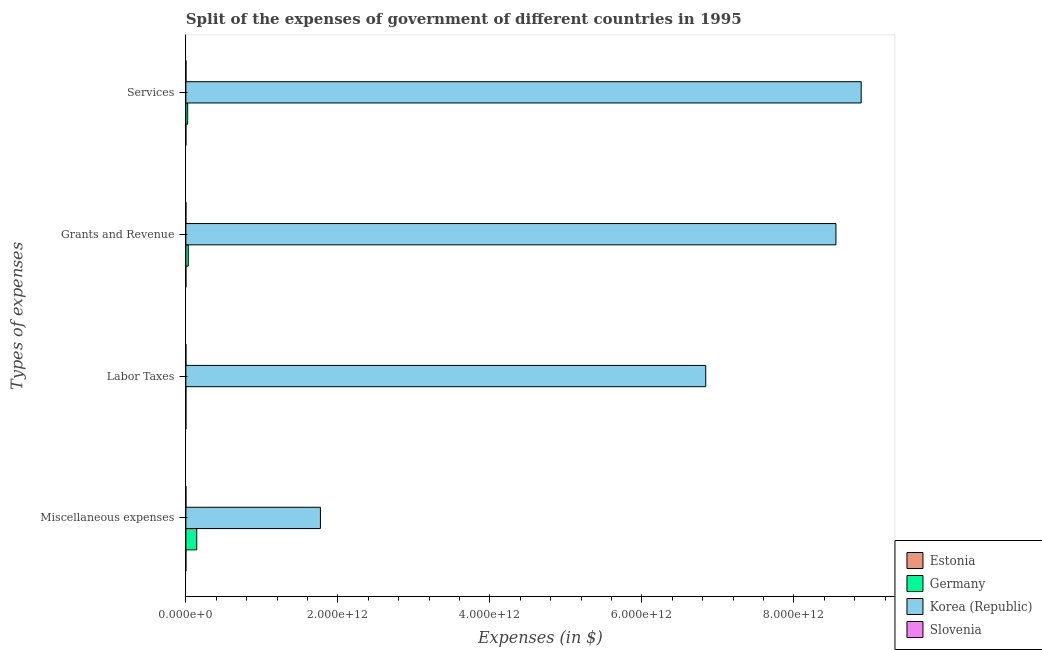How many groups of bars are there?
Your answer should be very brief. 4. Are the number of bars on each tick of the Y-axis equal?
Make the answer very short. Yes. How many bars are there on the 4th tick from the bottom?
Provide a succinct answer. 4. What is the label of the 3rd group of bars from the top?
Keep it short and to the point. Labor Taxes. What is the amount spent on labor taxes in Estonia?
Give a very brief answer. 2.84e+06. Across all countries, what is the maximum amount spent on miscellaneous expenses?
Give a very brief answer. 1.77e+12. Across all countries, what is the minimum amount spent on labor taxes?
Offer a very short reply. 2.84e+06. In which country was the amount spent on grants and revenue maximum?
Provide a succinct answer. Korea (Republic). In which country was the amount spent on services minimum?
Your response must be concise. Estonia. What is the total amount spent on labor taxes in the graph?
Give a very brief answer. 6.84e+12. What is the difference between the amount spent on services in Slovenia and that in Germany?
Ensure brevity in your answer.  -2.29e+1. What is the difference between the amount spent on services in Estonia and the amount spent on labor taxes in Slovenia?
Your answer should be compact. 1.77e+08. What is the average amount spent on labor taxes per country?
Keep it short and to the point. 1.71e+12. What is the difference between the amount spent on services and amount spent on labor taxes in Korea (Republic)?
Make the answer very short. 2.04e+12. What is the ratio of the amount spent on grants and revenue in Slovenia to that in Germany?
Your answer should be compact. 0. Is the amount spent on services in Germany less than that in Slovenia?
Ensure brevity in your answer.  No. Is the difference between the amount spent on grants and revenue in Germany and Korea (Republic) greater than the difference between the amount spent on miscellaneous expenses in Germany and Korea (Republic)?
Give a very brief answer. No. What is the difference between the highest and the second highest amount spent on labor taxes?
Offer a terse response. 6.84e+12. What is the difference between the highest and the lowest amount spent on labor taxes?
Provide a succinct answer. 6.84e+12. In how many countries, is the amount spent on grants and revenue greater than the average amount spent on grants and revenue taken over all countries?
Your answer should be compact. 1. Is it the case that in every country, the sum of the amount spent on grants and revenue and amount spent on miscellaneous expenses is greater than the sum of amount spent on labor taxes and amount spent on services?
Your response must be concise. No. What does the 1st bar from the bottom in Grants and Revenue represents?
Provide a succinct answer. Estonia. Is it the case that in every country, the sum of the amount spent on miscellaneous expenses and amount spent on labor taxes is greater than the amount spent on grants and revenue?
Your answer should be compact. No. Are all the bars in the graph horizontal?
Keep it short and to the point. Yes. What is the difference between two consecutive major ticks on the X-axis?
Offer a very short reply. 2.00e+12. Are the values on the major ticks of X-axis written in scientific E-notation?
Offer a terse response. Yes. How are the legend labels stacked?
Keep it short and to the point. Vertical. What is the title of the graph?
Your response must be concise. Split of the expenses of government of different countries in 1995. What is the label or title of the X-axis?
Ensure brevity in your answer.  Expenses (in $). What is the label or title of the Y-axis?
Ensure brevity in your answer.  Types of expenses. What is the Expenses (in $) of Estonia in Miscellaneous expenses?
Provide a succinct answer. 3.53e+07. What is the Expenses (in $) in Germany in Miscellaneous expenses?
Your answer should be very brief. 1.43e+11. What is the Expenses (in $) in Korea (Republic) in Miscellaneous expenses?
Your response must be concise. 1.77e+12. What is the Expenses (in $) of Slovenia in Miscellaneous expenses?
Offer a very short reply. 9.56e+07. What is the Expenses (in $) in Estonia in Labor Taxes?
Your answer should be compact. 2.84e+06. What is the Expenses (in $) in Germany in Labor Taxes?
Keep it short and to the point. 3.00e+07. What is the Expenses (in $) in Korea (Republic) in Labor Taxes?
Give a very brief answer. 6.84e+12. What is the Expenses (in $) of Slovenia in Labor Taxes?
Provide a succinct answer. 1.59e+07. What is the Expenses (in $) in Estonia in Grants and Revenue?
Provide a succinct answer. 1.30e+08. What is the Expenses (in $) in Germany in Grants and Revenue?
Offer a very short reply. 3.13e+1. What is the Expenses (in $) of Korea (Republic) in Grants and Revenue?
Make the answer very short. 8.55e+12. What is the Expenses (in $) in Slovenia in Grants and Revenue?
Give a very brief answer. 1.06e+08. What is the Expenses (in $) of Estonia in Services?
Your answer should be compact. 1.93e+08. What is the Expenses (in $) in Germany in Services?
Provide a succinct answer. 2.35e+1. What is the Expenses (in $) in Korea (Republic) in Services?
Ensure brevity in your answer.  8.88e+12. What is the Expenses (in $) of Slovenia in Services?
Make the answer very short. 6.69e+08. Across all Types of expenses, what is the maximum Expenses (in $) in Estonia?
Provide a succinct answer. 1.93e+08. Across all Types of expenses, what is the maximum Expenses (in $) in Germany?
Offer a very short reply. 1.43e+11. Across all Types of expenses, what is the maximum Expenses (in $) of Korea (Republic)?
Ensure brevity in your answer.  8.88e+12. Across all Types of expenses, what is the maximum Expenses (in $) in Slovenia?
Keep it short and to the point. 6.69e+08. Across all Types of expenses, what is the minimum Expenses (in $) of Estonia?
Make the answer very short. 2.84e+06. Across all Types of expenses, what is the minimum Expenses (in $) in Germany?
Make the answer very short. 3.00e+07. Across all Types of expenses, what is the minimum Expenses (in $) of Korea (Republic)?
Ensure brevity in your answer.  1.77e+12. Across all Types of expenses, what is the minimum Expenses (in $) in Slovenia?
Your answer should be very brief. 1.59e+07. What is the total Expenses (in $) of Estonia in the graph?
Make the answer very short. 3.62e+08. What is the total Expenses (in $) of Germany in the graph?
Your answer should be very brief. 1.98e+11. What is the total Expenses (in $) in Korea (Republic) in the graph?
Offer a very short reply. 2.60e+13. What is the total Expenses (in $) of Slovenia in the graph?
Your answer should be very brief. 8.87e+08. What is the difference between the Expenses (in $) of Estonia in Miscellaneous expenses and that in Labor Taxes?
Make the answer very short. 3.25e+07. What is the difference between the Expenses (in $) of Germany in Miscellaneous expenses and that in Labor Taxes?
Make the answer very short. 1.43e+11. What is the difference between the Expenses (in $) of Korea (Republic) in Miscellaneous expenses and that in Labor Taxes?
Offer a very short reply. -5.07e+12. What is the difference between the Expenses (in $) in Slovenia in Miscellaneous expenses and that in Labor Taxes?
Offer a very short reply. 7.97e+07. What is the difference between the Expenses (in $) of Estonia in Miscellaneous expenses and that in Grants and Revenue?
Your answer should be compact. -9.48e+07. What is the difference between the Expenses (in $) of Germany in Miscellaneous expenses and that in Grants and Revenue?
Offer a very short reply. 1.11e+11. What is the difference between the Expenses (in $) in Korea (Republic) in Miscellaneous expenses and that in Grants and Revenue?
Offer a terse response. -6.78e+12. What is the difference between the Expenses (in $) of Slovenia in Miscellaneous expenses and that in Grants and Revenue?
Your answer should be compact. -1.08e+07. What is the difference between the Expenses (in $) of Estonia in Miscellaneous expenses and that in Services?
Provide a short and direct response. -1.58e+08. What is the difference between the Expenses (in $) of Germany in Miscellaneous expenses and that in Services?
Provide a short and direct response. 1.19e+11. What is the difference between the Expenses (in $) in Korea (Republic) in Miscellaneous expenses and that in Services?
Provide a succinct answer. -7.11e+12. What is the difference between the Expenses (in $) of Slovenia in Miscellaneous expenses and that in Services?
Provide a succinct answer. -5.74e+08. What is the difference between the Expenses (in $) in Estonia in Labor Taxes and that in Grants and Revenue?
Keep it short and to the point. -1.27e+08. What is the difference between the Expenses (in $) of Germany in Labor Taxes and that in Grants and Revenue?
Your answer should be compact. -3.13e+1. What is the difference between the Expenses (in $) in Korea (Republic) in Labor Taxes and that in Grants and Revenue?
Your answer should be very brief. -1.71e+12. What is the difference between the Expenses (in $) of Slovenia in Labor Taxes and that in Grants and Revenue?
Your answer should be compact. -9.06e+07. What is the difference between the Expenses (in $) of Estonia in Labor Taxes and that in Services?
Keep it short and to the point. -1.90e+08. What is the difference between the Expenses (in $) of Germany in Labor Taxes and that in Services?
Provide a short and direct response. -2.35e+1. What is the difference between the Expenses (in $) of Korea (Republic) in Labor Taxes and that in Services?
Your answer should be very brief. -2.04e+12. What is the difference between the Expenses (in $) in Slovenia in Labor Taxes and that in Services?
Provide a succinct answer. -6.53e+08. What is the difference between the Expenses (in $) of Estonia in Grants and Revenue and that in Services?
Give a very brief answer. -6.32e+07. What is the difference between the Expenses (in $) of Germany in Grants and Revenue and that in Services?
Your answer should be very brief. 7.79e+09. What is the difference between the Expenses (in $) of Korea (Republic) in Grants and Revenue and that in Services?
Keep it short and to the point. -3.32e+11. What is the difference between the Expenses (in $) in Slovenia in Grants and Revenue and that in Services?
Your answer should be very brief. -5.63e+08. What is the difference between the Expenses (in $) of Estonia in Miscellaneous expenses and the Expenses (in $) of Germany in Labor Taxes?
Ensure brevity in your answer.  5.30e+06. What is the difference between the Expenses (in $) in Estonia in Miscellaneous expenses and the Expenses (in $) in Korea (Republic) in Labor Taxes?
Keep it short and to the point. -6.84e+12. What is the difference between the Expenses (in $) of Estonia in Miscellaneous expenses and the Expenses (in $) of Slovenia in Labor Taxes?
Keep it short and to the point. 1.94e+07. What is the difference between the Expenses (in $) in Germany in Miscellaneous expenses and the Expenses (in $) in Korea (Republic) in Labor Taxes?
Your answer should be compact. -6.70e+12. What is the difference between the Expenses (in $) in Germany in Miscellaneous expenses and the Expenses (in $) in Slovenia in Labor Taxes?
Provide a succinct answer. 1.43e+11. What is the difference between the Expenses (in $) in Korea (Republic) in Miscellaneous expenses and the Expenses (in $) in Slovenia in Labor Taxes?
Your answer should be very brief. 1.77e+12. What is the difference between the Expenses (in $) of Estonia in Miscellaneous expenses and the Expenses (in $) of Germany in Grants and Revenue?
Give a very brief answer. -3.13e+1. What is the difference between the Expenses (in $) of Estonia in Miscellaneous expenses and the Expenses (in $) of Korea (Republic) in Grants and Revenue?
Provide a short and direct response. -8.55e+12. What is the difference between the Expenses (in $) of Estonia in Miscellaneous expenses and the Expenses (in $) of Slovenia in Grants and Revenue?
Offer a very short reply. -7.11e+07. What is the difference between the Expenses (in $) of Germany in Miscellaneous expenses and the Expenses (in $) of Korea (Republic) in Grants and Revenue?
Your answer should be very brief. -8.41e+12. What is the difference between the Expenses (in $) in Germany in Miscellaneous expenses and the Expenses (in $) in Slovenia in Grants and Revenue?
Offer a very short reply. 1.43e+11. What is the difference between the Expenses (in $) of Korea (Republic) in Miscellaneous expenses and the Expenses (in $) of Slovenia in Grants and Revenue?
Make the answer very short. 1.77e+12. What is the difference between the Expenses (in $) in Estonia in Miscellaneous expenses and the Expenses (in $) in Germany in Services?
Offer a very short reply. -2.35e+1. What is the difference between the Expenses (in $) in Estonia in Miscellaneous expenses and the Expenses (in $) in Korea (Republic) in Services?
Offer a very short reply. -8.88e+12. What is the difference between the Expenses (in $) of Estonia in Miscellaneous expenses and the Expenses (in $) of Slovenia in Services?
Your answer should be compact. -6.34e+08. What is the difference between the Expenses (in $) in Germany in Miscellaneous expenses and the Expenses (in $) in Korea (Republic) in Services?
Offer a very short reply. -8.74e+12. What is the difference between the Expenses (in $) in Germany in Miscellaneous expenses and the Expenses (in $) in Slovenia in Services?
Offer a terse response. 1.42e+11. What is the difference between the Expenses (in $) in Korea (Republic) in Miscellaneous expenses and the Expenses (in $) in Slovenia in Services?
Your response must be concise. 1.77e+12. What is the difference between the Expenses (in $) in Estonia in Labor Taxes and the Expenses (in $) in Germany in Grants and Revenue?
Give a very brief answer. -3.13e+1. What is the difference between the Expenses (in $) of Estonia in Labor Taxes and the Expenses (in $) of Korea (Republic) in Grants and Revenue?
Make the answer very short. -8.55e+12. What is the difference between the Expenses (in $) of Estonia in Labor Taxes and the Expenses (in $) of Slovenia in Grants and Revenue?
Provide a short and direct response. -1.04e+08. What is the difference between the Expenses (in $) of Germany in Labor Taxes and the Expenses (in $) of Korea (Republic) in Grants and Revenue?
Provide a short and direct response. -8.55e+12. What is the difference between the Expenses (in $) in Germany in Labor Taxes and the Expenses (in $) in Slovenia in Grants and Revenue?
Ensure brevity in your answer.  -7.64e+07. What is the difference between the Expenses (in $) in Korea (Republic) in Labor Taxes and the Expenses (in $) in Slovenia in Grants and Revenue?
Your answer should be compact. 6.84e+12. What is the difference between the Expenses (in $) of Estonia in Labor Taxes and the Expenses (in $) of Germany in Services?
Provide a short and direct response. -2.35e+1. What is the difference between the Expenses (in $) in Estonia in Labor Taxes and the Expenses (in $) in Korea (Republic) in Services?
Make the answer very short. -8.88e+12. What is the difference between the Expenses (in $) in Estonia in Labor Taxes and the Expenses (in $) in Slovenia in Services?
Keep it short and to the point. -6.66e+08. What is the difference between the Expenses (in $) of Germany in Labor Taxes and the Expenses (in $) of Korea (Republic) in Services?
Make the answer very short. -8.88e+12. What is the difference between the Expenses (in $) in Germany in Labor Taxes and the Expenses (in $) in Slovenia in Services?
Keep it short and to the point. -6.39e+08. What is the difference between the Expenses (in $) in Korea (Republic) in Labor Taxes and the Expenses (in $) in Slovenia in Services?
Give a very brief answer. 6.84e+12. What is the difference between the Expenses (in $) of Estonia in Grants and Revenue and the Expenses (in $) of Germany in Services?
Offer a terse response. -2.34e+1. What is the difference between the Expenses (in $) of Estonia in Grants and Revenue and the Expenses (in $) of Korea (Republic) in Services?
Offer a terse response. -8.88e+12. What is the difference between the Expenses (in $) in Estonia in Grants and Revenue and the Expenses (in $) in Slovenia in Services?
Keep it short and to the point. -5.39e+08. What is the difference between the Expenses (in $) of Germany in Grants and Revenue and the Expenses (in $) of Korea (Republic) in Services?
Provide a succinct answer. -8.85e+12. What is the difference between the Expenses (in $) of Germany in Grants and Revenue and the Expenses (in $) of Slovenia in Services?
Ensure brevity in your answer.  3.07e+1. What is the difference between the Expenses (in $) in Korea (Republic) in Grants and Revenue and the Expenses (in $) in Slovenia in Services?
Your answer should be compact. 8.55e+12. What is the average Expenses (in $) in Estonia per Types of expenses?
Make the answer very short. 9.04e+07. What is the average Expenses (in $) of Germany per Types of expenses?
Provide a short and direct response. 4.94e+1. What is the average Expenses (in $) in Korea (Republic) per Types of expenses?
Give a very brief answer. 6.51e+12. What is the average Expenses (in $) of Slovenia per Types of expenses?
Provide a succinct answer. 2.22e+08. What is the difference between the Expenses (in $) of Estonia and Expenses (in $) of Germany in Miscellaneous expenses?
Ensure brevity in your answer.  -1.43e+11. What is the difference between the Expenses (in $) in Estonia and Expenses (in $) in Korea (Republic) in Miscellaneous expenses?
Provide a short and direct response. -1.77e+12. What is the difference between the Expenses (in $) in Estonia and Expenses (in $) in Slovenia in Miscellaneous expenses?
Your answer should be very brief. -6.03e+07. What is the difference between the Expenses (in $) in Germany and Expenses (in $) in Korea (Republic) in Miscellaneous expenses?
Your answer should be very brief. -1.63e+12. What is the difference between the Expenses (in $) of Germany and Expenses (in $) of Slovenia in Miscellaneous expenses?
Your answer should be compact. 1.43e+11. What is the difference between the Expenses (in $) in Korea (Republic) and Expenses (in $) in Slovenia in Miscellaneous expenses?
Ensure brevity in your answer.  1.77e+12. What is the difference between the Expenses (in $) of Estonia and Expenses (in $) of Germany in Labor Taxes?
Make the answer very short. -2.72e+07. What is the difference between the Expenses (in $) in Estonia and Expenses (in $) in Korea (Republic) in Labor Taxes?
Keep it short and to the point. -6.84e+12. What is the difference between the Expenses (in $) of Estonia and Expenses (in $) of Slovenia in Labor Taxes?
Offer a very short reply. -1.30e+07. What is the difference between the Expenses (in $) in Germany and Expenses (in $) in Korea (Republic) in Labor Taxes?
Keep it short and to the point. -6.84e+12. What is the difference between the Expenses (in $) of Germany and Expenses (in $) of Slovenia in Labor Taxes?
Make the answer very short. 1.41e+07. What is the difference between the Expenses (in $) in Korea (Republic) and Expenses (in $) in Slovenia in Labor Taxes?
Your answer should be very brief. 6.84e+12. What is the difference between the Expenses (in $) in Estonia and Expenses (in $) in Germany in Grants and Revenue?
Provide a short and direct response. -3.12e+1. What is the difference between the Expenses (in $) in Estonia and Expenses (in $) in Korea (Republic) in Grants and Revenue?
Your answer should be very brief. -8.55e+12. What is the difference between the Expenses (in $) in Estonia and Expenses (in $) in Slovenia in Grants and Revenue?
Give a very brief answer. 2.37e+07. What is the difference between the Expenses (in $) of Germany and Expenses (in $) of Korea (Republic) in Grants and Revenue?
Give a very brief answer. -8.52e+12. What is the difference between the Expenses (in $) in Germany and Expenses (in $) in Slovenia in Grants and Revenue?
Offer a very short reply. 3.12e+1. What is the difference between the Expenses (in $) in Korea (Republic) and Expenses (in $) in Slovenia in Grants and Revenue?
Your answer should be compact. 8.55e+12. What is the difference between the Expenses (in $) of Estonia and Expenses (in $) of Germany in Services?
Make the answer very short. -2.33e+1. What is the difference between the Expenses (in $) of Estonia and Expenses (in $) of Korea (Republic) in Services?
Make the answer very short. -8.88e+12. What is the difference between the Expenses (in $) in Estonia and Expenses (in $) in Slovenia in Services?
Offer a terse response. -4.76e+08. What is the difference between the Expenses (in $) of Germany and Expenses (in $) of Korea (Republic) in Services?
Make the answer very short. -8.86e+12. What is the difference between the Expenses (in $) of Germany and Expenses (in $) of Slovenia in Services?
Make the answer very short. 2.29e+1. What is the difference between the Expenses (in $) of Korea (Republic) and Expenses (in $) of Slovenia in Services?
Your answer should be very brief. 8.88e+12. What is the ratio of the Expenses (in $) in Estonia in Miscellaneous expenses to that in Labor Taxes?
Provide a succinct answer. 12.43. What is the ratio of the Expenses (in $) of Germany in Miscellaneous expenses to that in Labor Taxes?
Your response must be concise. 4761. What is the ratio of the Expenses (in $) of Korea (Republic) in Miscellaneous expenses to that in Labor Taxes?
Your response must be concise. 0.26. What is the ratio of the Expenses (in $) of Slovenia in Miscellaneous expenses to that in Labor Taxes?
Provide a short and direct response. 6.03. What is the ratio of the Expenses (in $) in Estonia in Miscellaneous expenses to that in Grants and Revenue?
Keep it short and to the point. 0.27. What is the ratio of the Expenses (in $) of Germany in Miscellaneous expenses to that in Grants and Revenue?
Your answer should be compact. 4.56. What is the ratio of the Expenses (in $) in Korea (Republic) in Miscellaneous expenses to that in Grants and Revenue?
Your answer should be very brief. 0.21. What is the ratio of the Expenses (in $) of Slovenia in Miscellaneous expenses to that in Grants and Revenue?
Offer a terse response. 0.9. What is the ratio of the Expenses (in $) of Estonia in Miscellaneous expenses to that in Services?
Your response must be concise. 0.18. What is the ratio of the Expenses (in $) of Germany in Miscellaneous expenses to that in Services?
Your response must be concise. 6.07. What is the ratio of the Expenses (in $) in Korea (Republic) in Miscellaneous expenses to that in Services?
Keep it short and to the point. 0.2. What is the ratio of the Expenses (in $) of Slovenia in Miscellaneous expenses to that in Services?
Your answer should be compact. 0.14. What is the ratio of the Expenses (in $) of Estonia in Labor Taxes to that in Grants and Revenue?
Keep it short and to the point. 0.02. What is the ratio of the Expenses (in $) of Korea (Republic) in Labor Taxes to that in Grants and Revenue?
Ensure brevity in your answer.  0.8. What is the ratio of the Expenses (in $) in Slovenia in Labor Taxes to that in Grants and Revenue?
Give a very brief answer. 0.15. What is the ratio of the Expenses (in $) of Estonia in Labor Taxes to that in Services?
Provide a short and direct response. 0.01. What is the ratio of the Expenses (in $) in Germany in Labor Taxes to that in Services?
Ensure brevity in your answer.  0. What is the ratio of the Expenses (in $) in Korea (Republic) in Labor Taxes to that in Services?
Provide a succinct answer. 0.77. What is the ratio of the Expenses (in $) of Slovenia in Labor Taxes to that in Services?
Your response must be concise. 0.02. What is the ratio of the Expenses (in $) in Estonia in Grants and Revenue to that in Services?
Keep it short and to the point. 0.67. What is the ratio of the Expenses (in $) in Germany in Grants and Revenue to that in Services?
Give a very brief answer. 1.33. What is the ratio of the Expenses (in $) in Korea (Republic) in Grants and Revenue to that in Services?
Your response must be concise. 0.96. What is the ratio of the Expenses (in $) in Slovenia in Grants and Revenue to that in Services?
Your answer should be compact. 0.16. What is the difference between the highest and the second highest Expenses (in $) in Estonia?
Give a very brief answer. 6.32e+07. What is the difference between the highest and the second highest Expenses (in $) of Germany?
Provide a succinct answer. 1.11e+11. What is the difference between the highest and the second highest Expenses (in $) in Korea (Republic)?
Your answer should be compact. 3.32e+11. What is the difference between the highest and the second highest Expenses (in $) of Slovenia?
Offer a terse response. 5.63e+08. What is the difference between the highest and the lowest Expenses (in $) of Estonia?
Your response must be concise. 1.90e+08. What is the difference between the highest and the lowest Expenses (in $) in Germany?
Provide a succinct answer. 1.43e+11. What is the difference between the highest and the lowest Expenses (in $) in Korea (Republic)?
Make the answer very short. 7.11e+12. What is the difference between the highest and the lowest Expenses (in $) in Slovenia?
Offer a very short reply. 6.53e+08. 